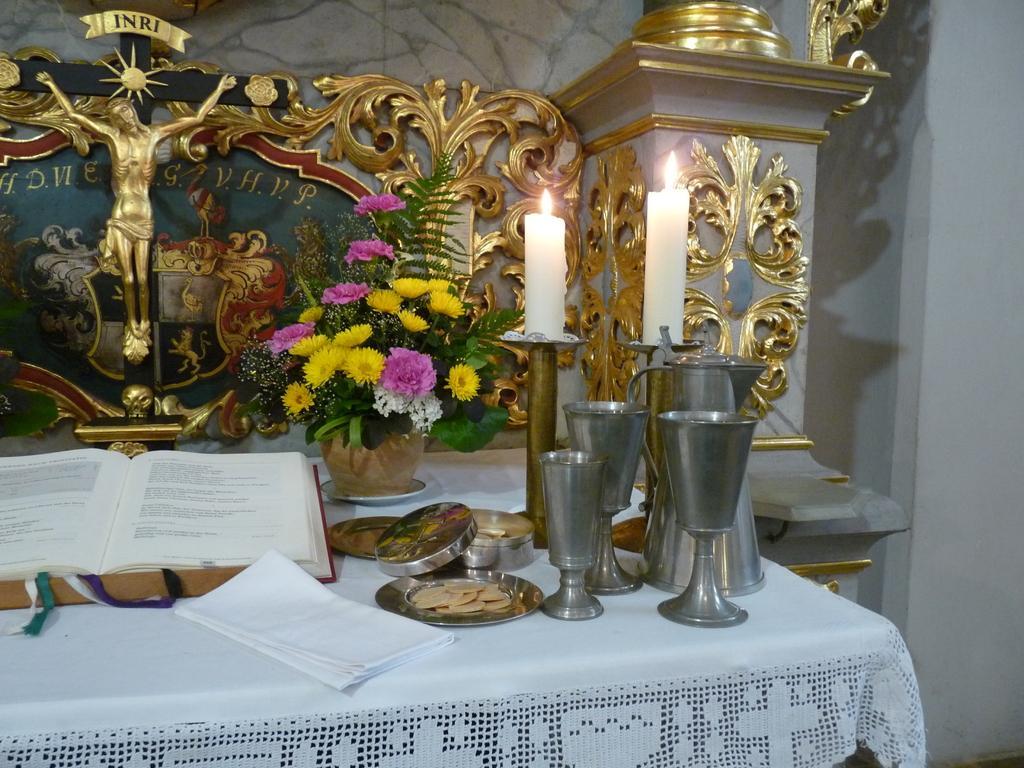Can you describe this image briefly? In this image we can see book, some plates, glasses, tissues which are on table and in the background of the image there is sculpture of Jesus, there are some objects, candles and flower vase. 